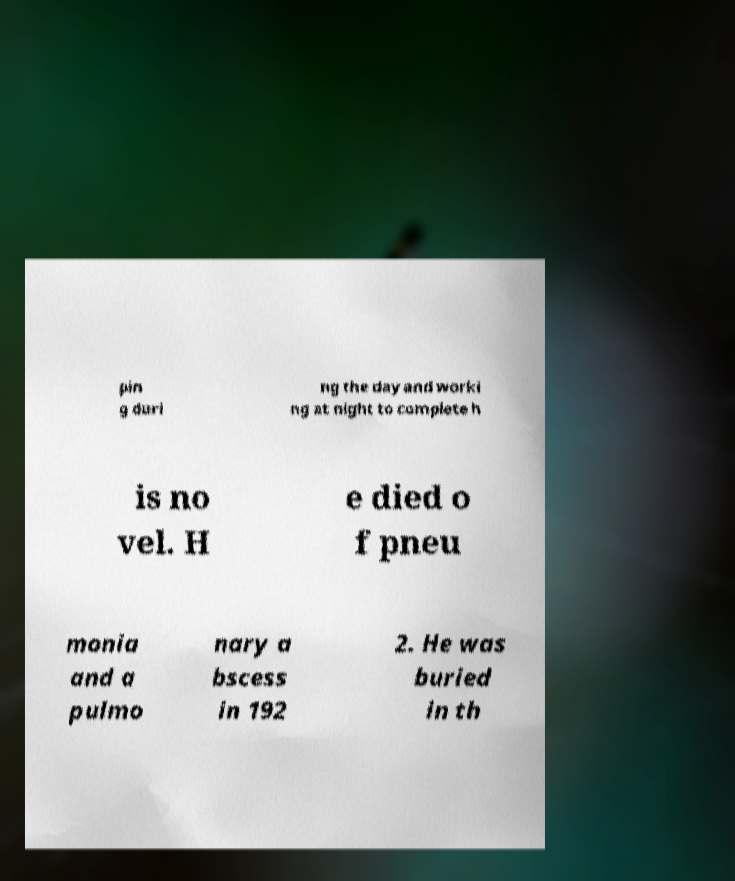Can you accurately transcribe the text from the provided image for me? pin g duri ng the day and worki ng at night to complete h is no vel. H e died o f pneu monia and a pulmo nary a bscess in 192 2. He was buried in th 